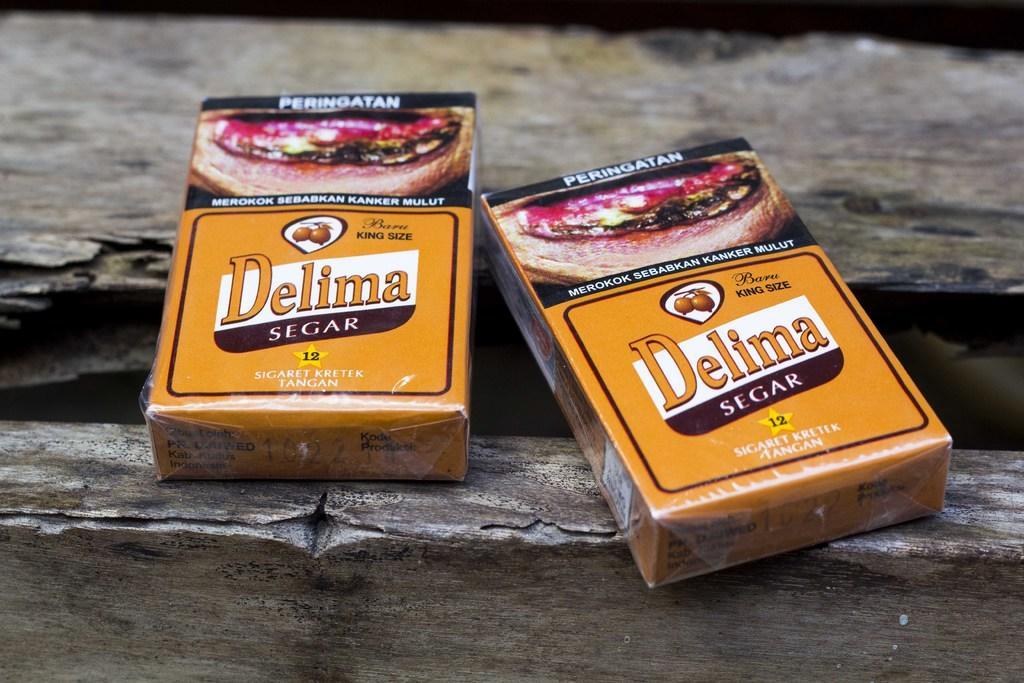Describe this image in one or two sentences. In the picture there are two cigarette packets present, on the pack there is some text present. 